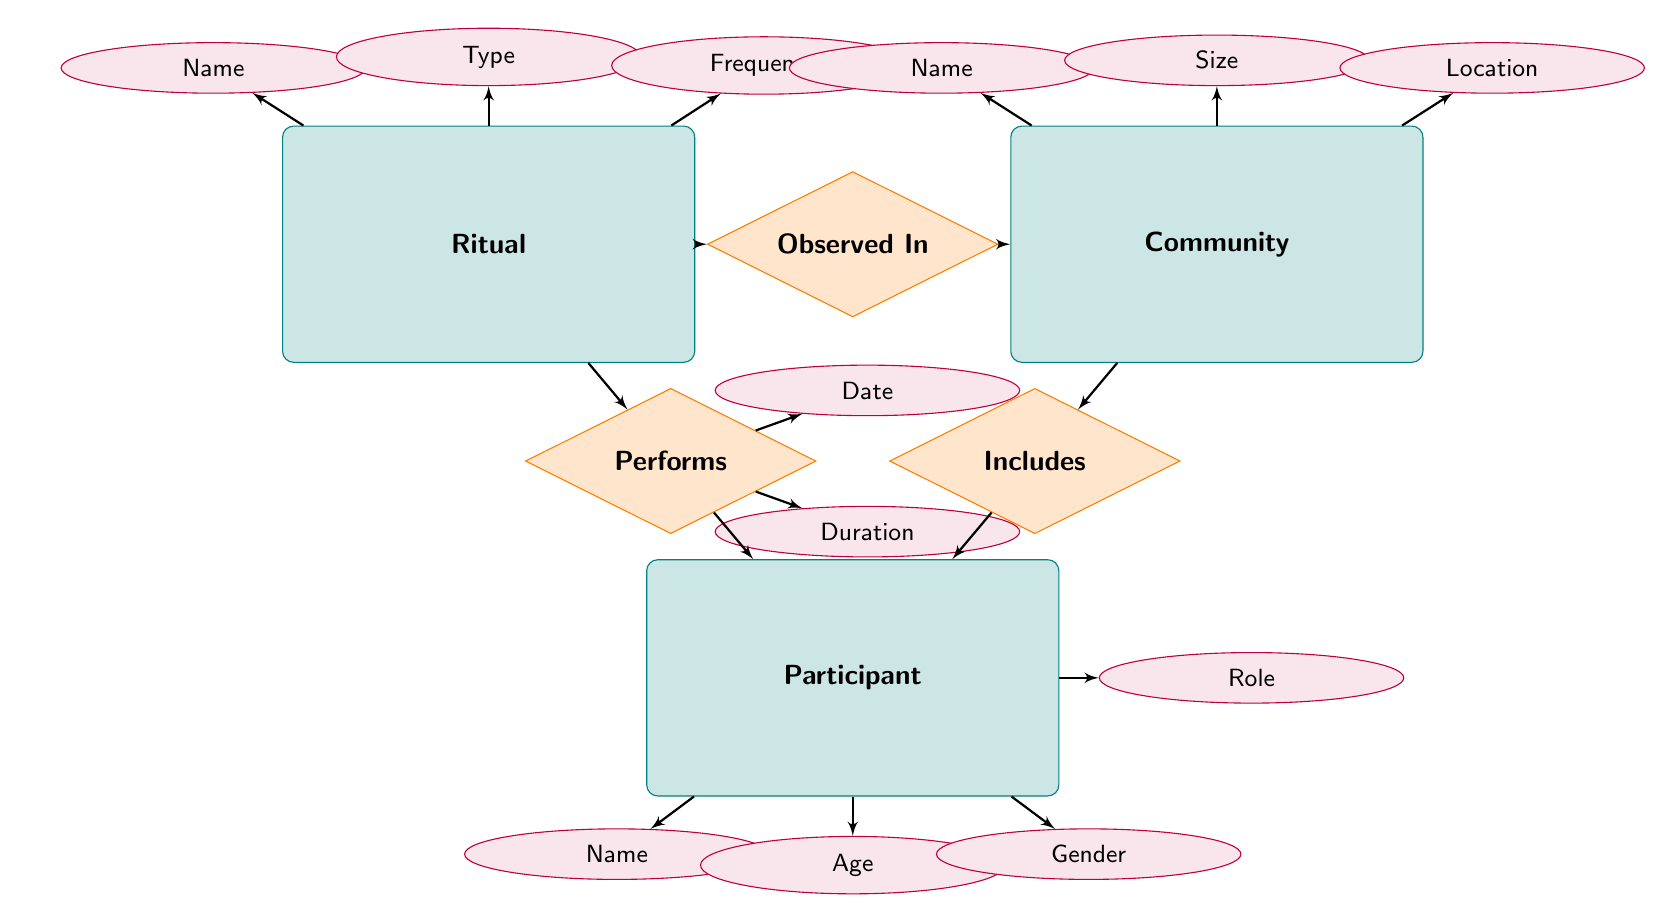What is the relationship between Ritual and Community? The diagram indicates that the relationship between the Ritual and Community entities is "Observed In." This means that rituals are noticed or carried out within a certain community.
Answer: Observed In How many attributes does the Participant entity have? Looking at the Participant entity in the diagram, it displays four attributes: Name, Age, Gender, and Role. Therefore, counting these gives a total of four attributes.
Answer: Four Which entity has the attribute "Size"? In the diagram, the "Size" attribute is associated with the Community entity. This can be determined by identifying the attributes listed under each entity.
Answer: Community What relationship connects Community and Participant? The relationship that connects Community and Participant is labeled "Includes." This is evident from the arrow linking these two entities in the diagram.
Answer: Includes What is the attribute associated with the Performs relationship? The relationship "Performs" contains two attributes: "Date" and "Duration." Both of these attributes are linked to the Performs relationship in the diagram.
Answer: Date, Duration What are the attributes of the Ritual entity? The Ritual entity has three attributes listed: Name, Type, and Frequency. This can be verified by checking the attributes connected to the Ritual entity.
Answer: Name, Type, Frequency How many entities are depicted in the diagram? The diagram contains three distinct entities: Ritual, Community, and Participant. Counting each of these entities gives a total of three.
Answer: Three What type of diagram is this? The diagram represents an Entity Relationship Diagram, which is specifically used to illustrate the relationships between entities in a database or system context.
Answer: Entity Relationship Diagram What can be inferred about the roles of Participants in Rituals? The presence of the "Performs" relationship indicates that Participants partake in Rituals, which implies active involvement and a defined role in the context of the ritual practices.
Answer: Active involvement 